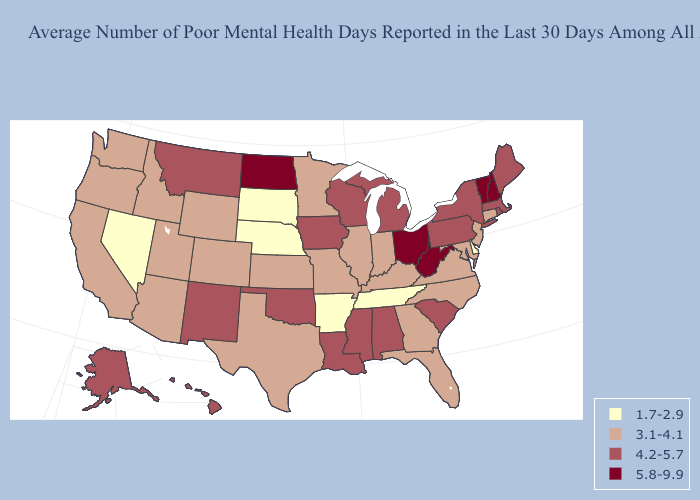Which states have the lowest value in the USA?
Give a very brief answer. Arkansas, Delaware, Nebraska, Nevada, South Dakota, Tennessee. Name the states that have a value in the range 4.2-5.7?
Write a very short answer. Alabama, Alaska, Hawaii, Iowa, Louisiana, Maine, Massachusetts, Michigan, Mississippi, Montana, New Mexico, New York, Oklahoma, Pennsylvania, Rhode Island, South Carolina, Wisconsin. Name the states that have a value in the range 5.8-9.9?
Answer briefly. New Hampshire, North Dakota, Ohio, Vermont, West Virginia. Among the states that border Idaho , does Nevada have the lowest value?
Be succinct. Yes. Does North Dakota have the highest value in the USA?
Write a very short answer. Yes. Among the states that border Maine , which have the lowest value?
Give a very brief answer. New Hampshire. Name the states that have a value in the range 3.1-4.1?
Answer briefly. Arizona, California, Colorado, Connecticut, Florida, Georgia, Idaho, Illinois, Indiana, Kansas, Kentucky, Maryland, Minnesota, Missouri, New Jersey, North Carolina, Oregon, Texas, Utah, Virginia, Washington, Wyoming. Among the states that border Arkansas , which have the highest value?
Keep it brief. Louisiana, Mississippi, Oklahoma. What is the lowest value in states that border Washington?
Concise answer only. 3.1-4.1. Which states have the lowest value in the West?
Be succinct. Nevada. Does Wisconsin have a higher value than Maine?
Quick response, please. No. What is the highest value in the Northeast ?
Concise answer only. 5.8-9.9. Name the states that have a value in the range 4.2-5.7?
Keep it brief. Alabama, Alaska, Hawaii, Iowa, Louisiana, Maine, Massachusetts, Michigan, Mississippi, Montana, New Mexico, New York, Oklahoma, Pennsylvania, Rhode Island, South Carolina, Wisconsin. Does Connecticut have a lower value than Nevada?
Quick response, please. No. Among the states that border Colorado , which have the highest value?
Give a very brief answer. New Mexico, Oklahoma. 